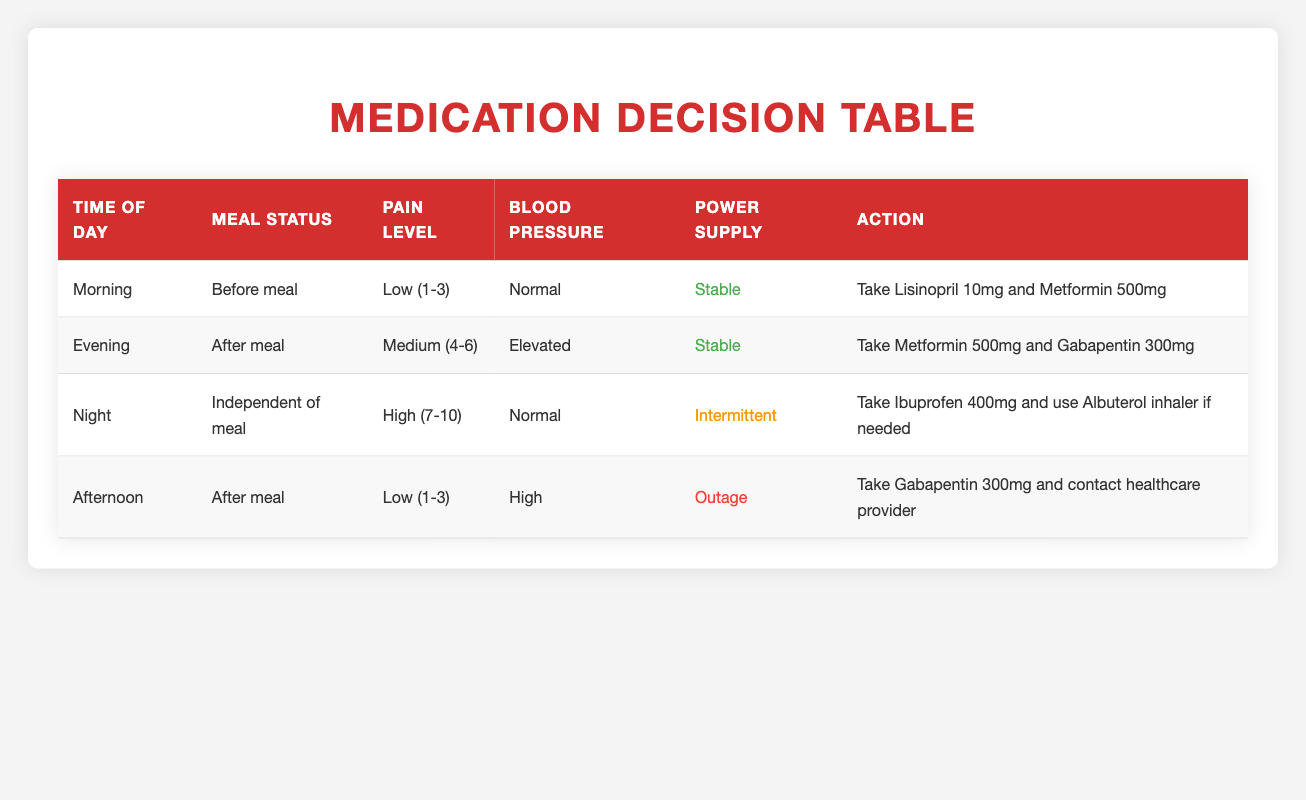What medication should be taken in the morning? According to the table, for the morning time with a before meal status, low pain level, normal blood pressure, and stable power supply, the action is to take Lisinopril 10mg and Metformin 500mg.
Answer: Lisinopril 10mg and Metformin 500mg Is there an action for evening when the meal status is after meal and pain level is high? The table specifies actions for evening with after meal status and medium pain level, not high. There is no action listed for high pain level during the evening.
Answer: No What is the power supply status when taking Gabapentin in the afternoon? In the afternoon, if the meal status is after meal, low pain level, and high blood pressure, the power supply status is an outage according to the table.
Answer: Outage What medications are taken when blood pressure is elevated? The table shows two instances where blood pressure is elevated: in the evening, the action is to take Metformin 500mg and Gabapentin 300mg; however, in the afternoon, it recommends taking Gabapentin 300mg and contacting a healthcare provider.
Answer: Metformin 500mg and Gabapentin 300mg; Gabapentin 300mg What is the relationship between pain level and action during the night? During the night, when the pain level is high, the action is to take Ibuprofen 400mg and use the Albuterol inhaler if needed, without reference to how it relates to other pain levels. It indicates that high pain requires specific actions.
Answer: Take Ibuprofen 400mg and use Albuterol inhaler if needed 